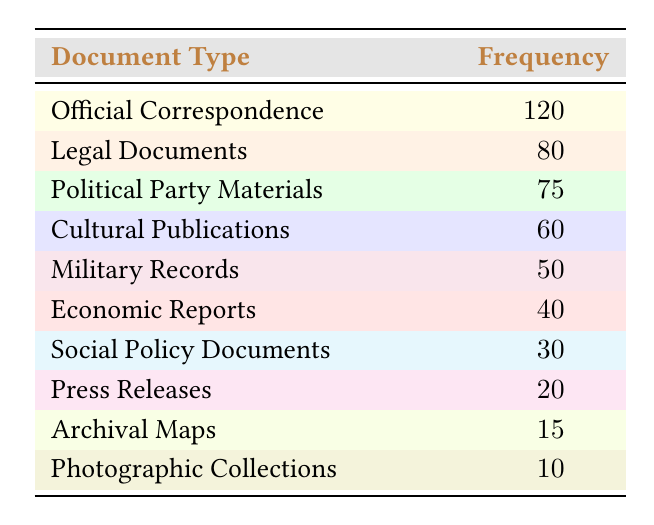What is the frequency of Official Correspondence? Official Correspondence has a frequency of 120, as listed in the table.
Answer: 120 How many more Legal Documents are there compared to Economic Reports? The frequency of Legal Documents is 80, and the frequency of Economic Reports is 40. The difference is 80 - 40 = 40.
Answer: 40 Is the frequency of Political Party Materials greater than Cultural Publications? The frequency of Political Party Materials is 75 and Cultural Publications is 60. Since 75 is greater than 60, the answer is yes.
Answer: Yes What is the total frequency of all document types listed? Adding all frequencies: 120 + 80 + 75 + 60 + 50 + 40 + 30 + 20 + 15 + 10 = 480.
Answer: 480 What percentage of the total frequency does Military Records represent? First, Military Records frequency is 50. Total frequency is 480. The percentage is (50 / 480) * 100 ≈ 10.42%.
Answer: 10.42% How many document types have a frequency of 30 or less? The frequencies of Social Policy Documents (30), Press Releases (20), Archival Maps (15), and Photographic Collections (10) all meet this criterion. So, there are 4 such document types.
Answer: 4 Is there a document type with a frequency lower than 10? The lowest frequency is Photographic Collections with 10. Since this is not lower than 10, the answer is no.
Answer: No What is the average frequency of the document types listed? Total frequency is 480, and there are 10 document types. The average frequency is 480 / 10 = 48.
Answer: 48 What is the difference in frequency between the most and least common document types? The most common is Official Correspondence (120) and the least is Photographic Collections (10). The difference is 120 - 10 = 110.
Answer: 110 